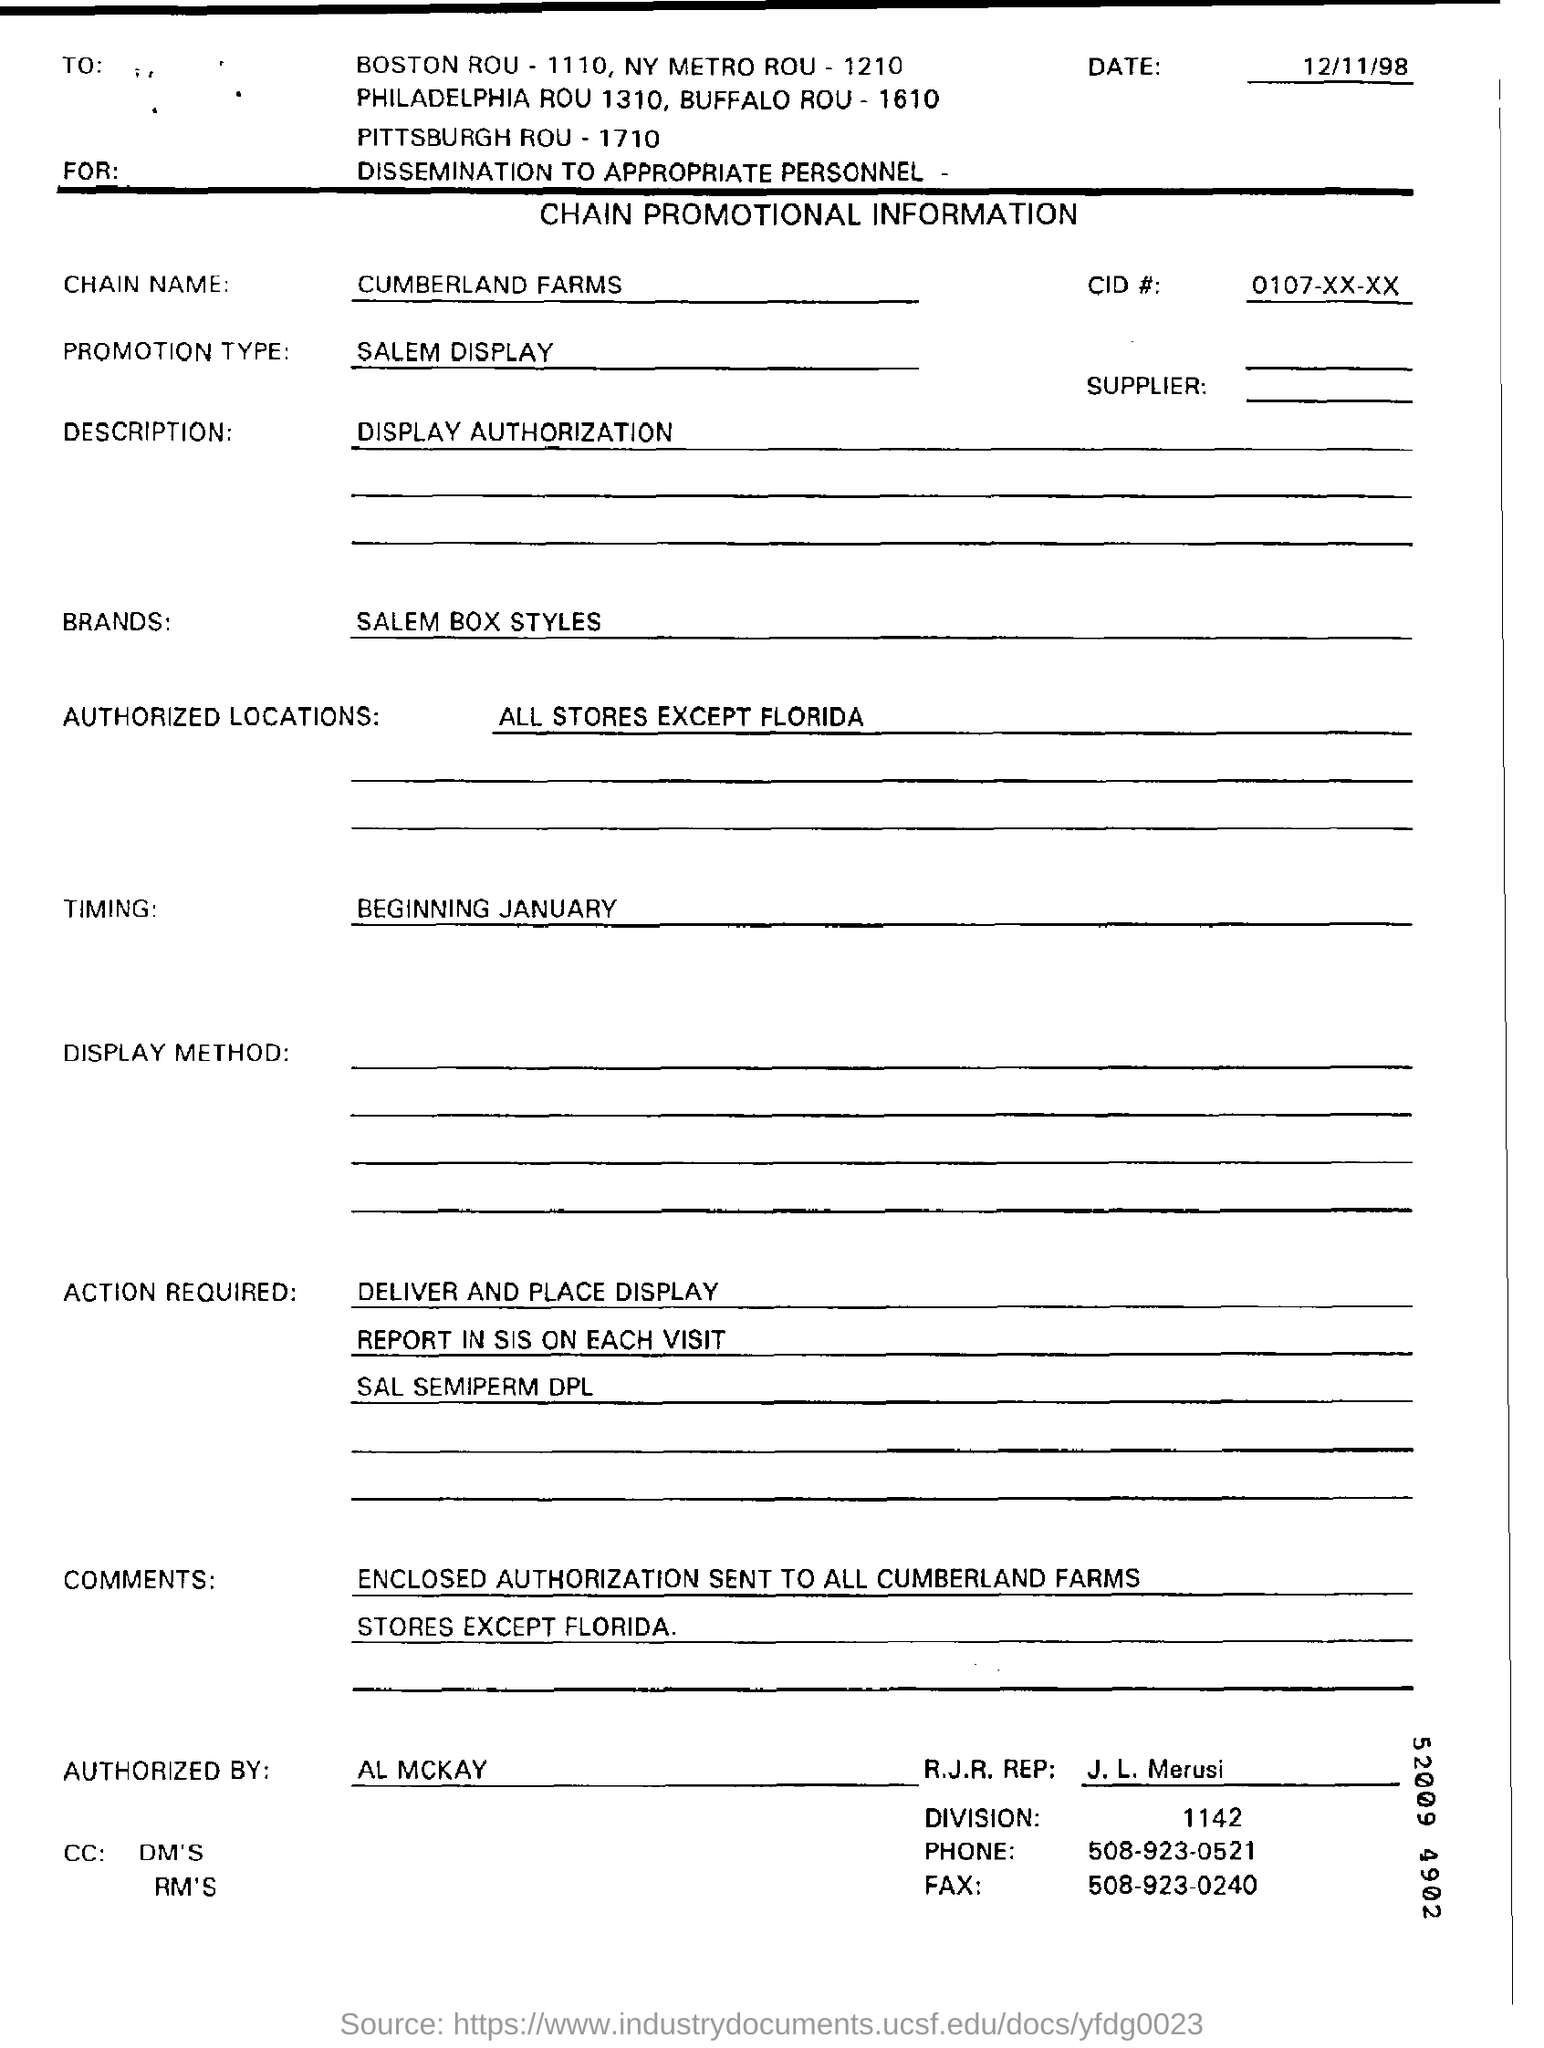Draw attention to some important aspects in this diagram. Timing refers to the process of measuring and controlling the duration or interval between events or actions. The brand name is Salem Box Styles. 